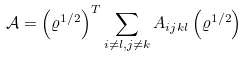Convert formula to latex. <formula><loc_0><loc_0><loc_500><loc_500>\mathcal { A } = \left ( \varrho ^ { 1 / 2 } \right ) ^ { T } \sum _ { i \neq l , j \neq k } A _ { i j k l } \left ( \varrho ^ { 1 / 2 } \right )</formula> 